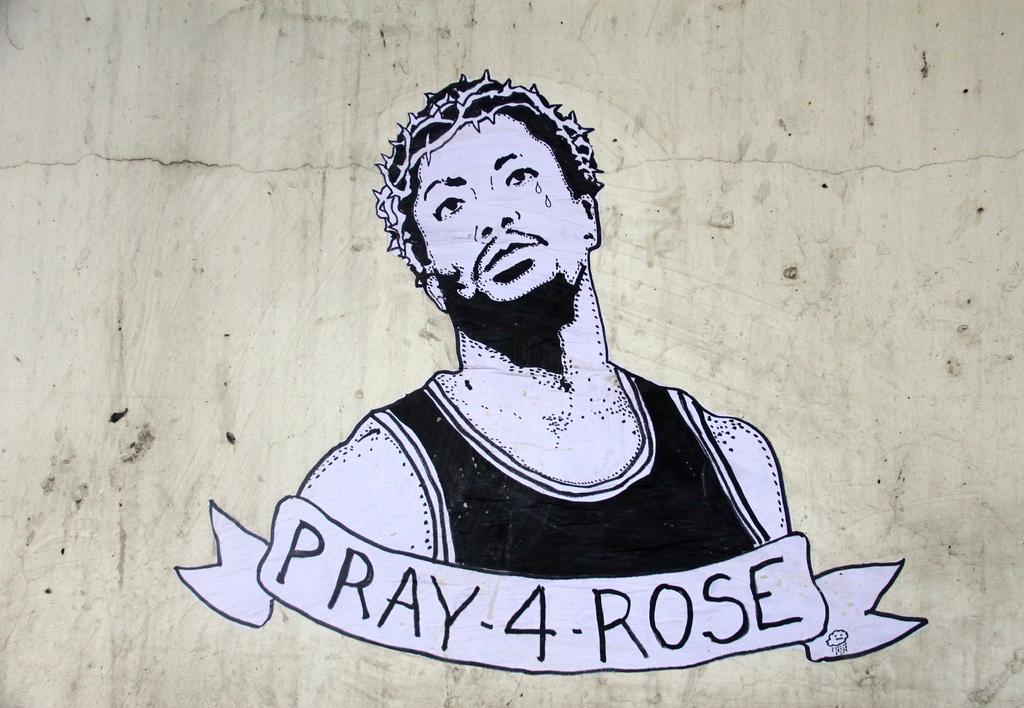What is the main subject of the image? The main subject of the image is a picture of a man. What additional feature is present on the picture of the man? The picture of the man has text on it. Where is the picture of the man with text located? The picture of the man with text is pasted on a wall. What type of marble is used to create the peace symbol in the image? There is no marble or peace symbol present in the image. The image features a picture of a man with text on it, which is pasted on a wall. 